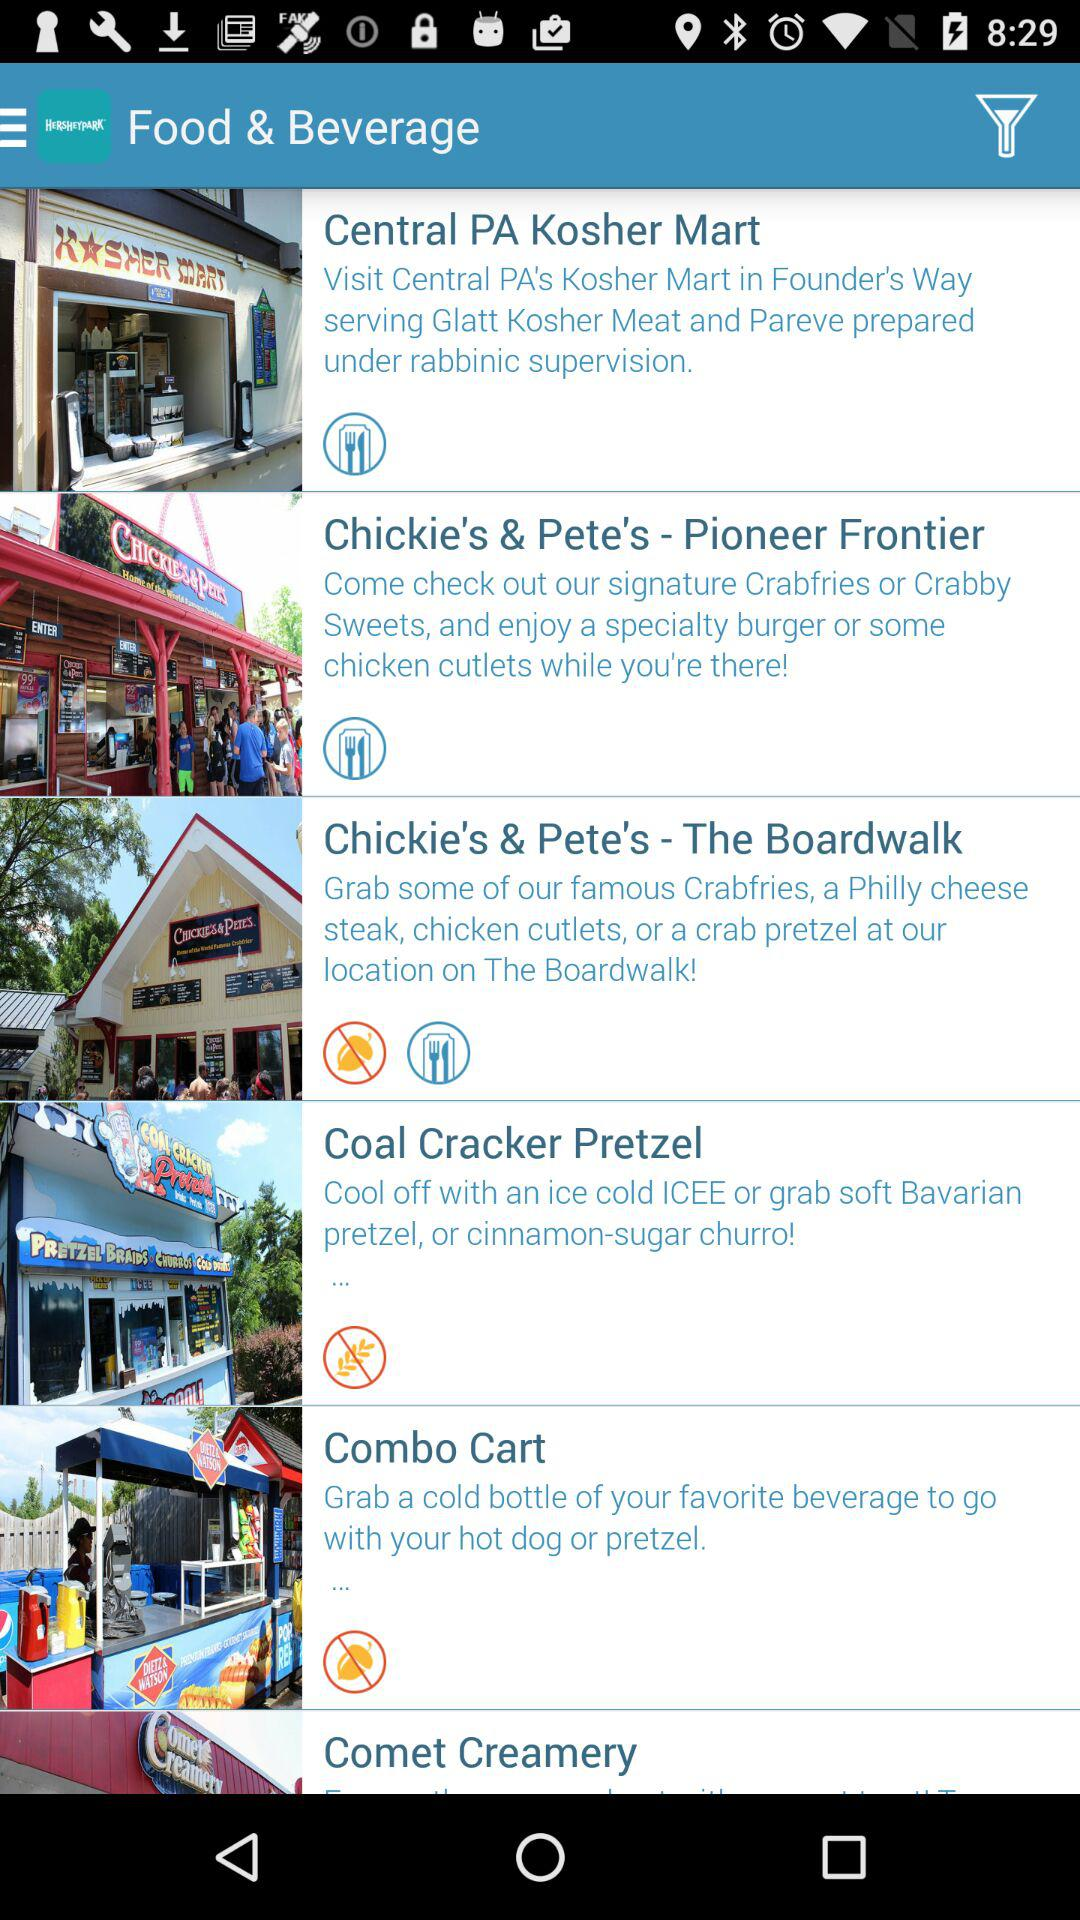Which shop has no food option?
When the provided information is insufficient, respond with <no answer>. <no answer> 